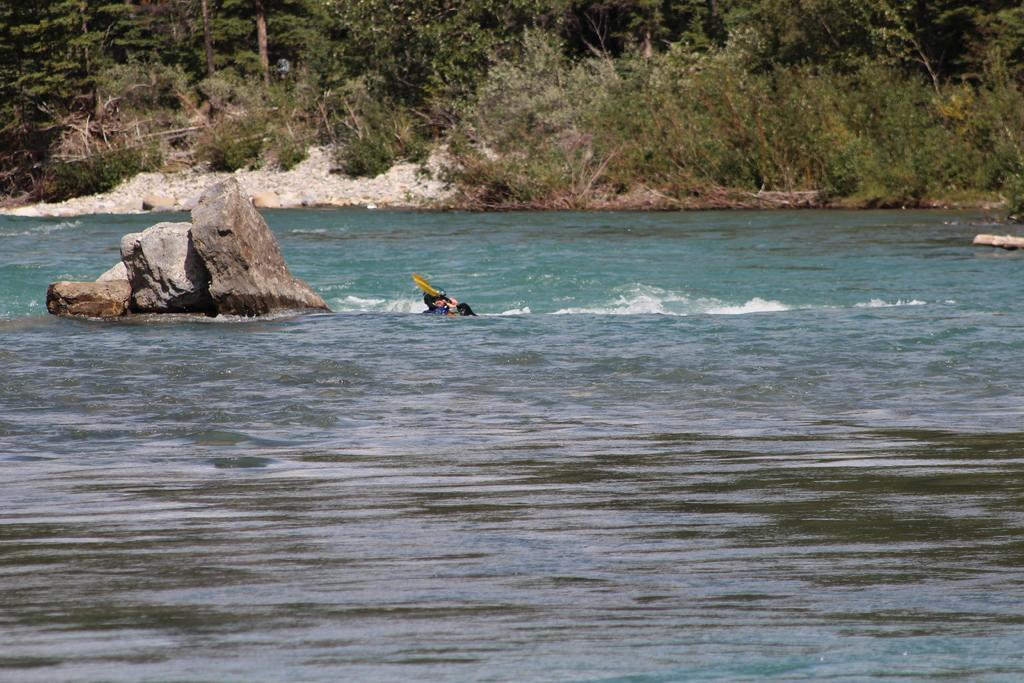Can you describe this image briefly? In the image,there is a man swimming in the water and behind the man there is a big rock in between the water and in the background there are plenty of trees. 